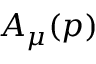Convert formula to latex. <formula><loc_0><loc_0><loc_500><loc_500>A _ { \mu } ( p )</formula> 